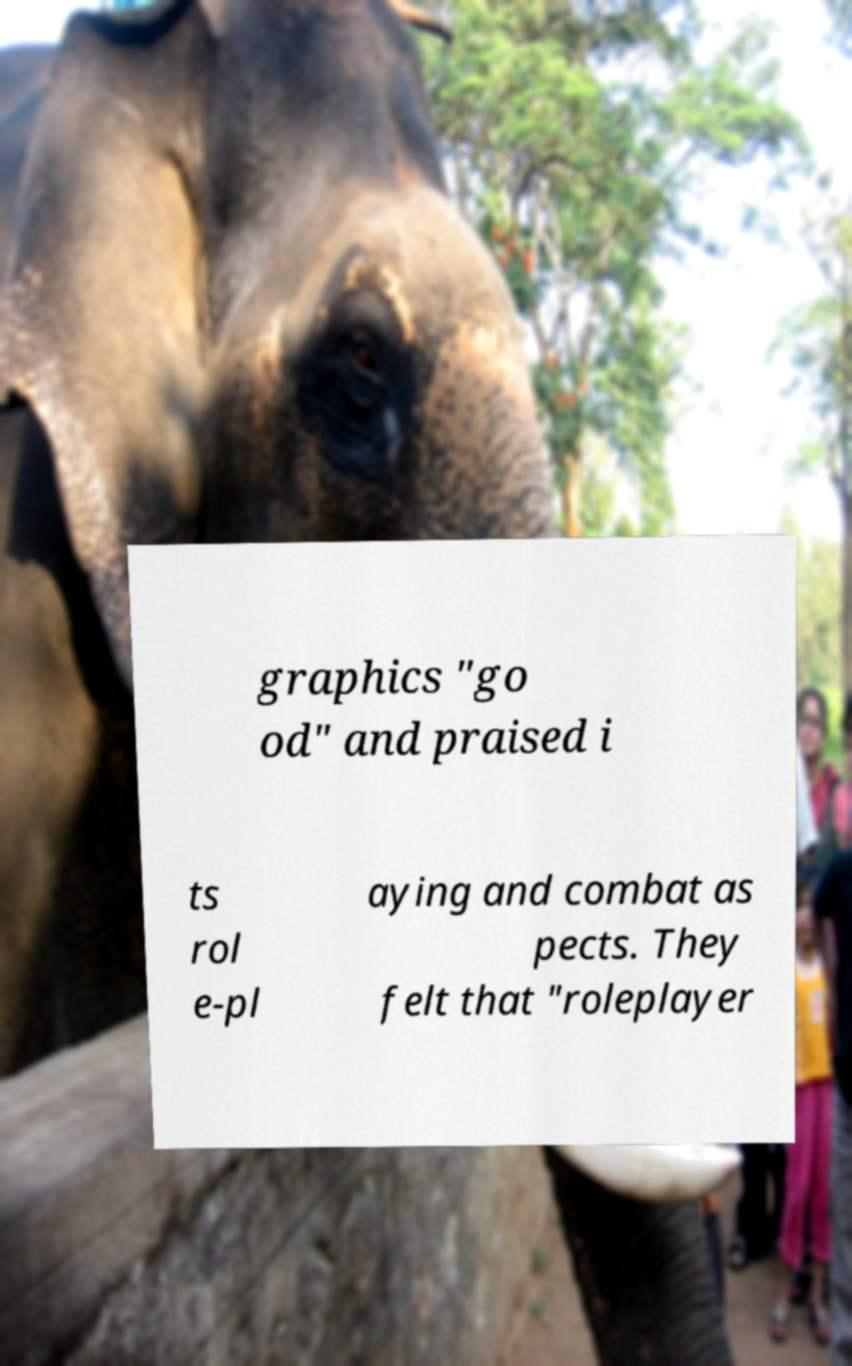Please read and relay the text visible in this image. What does it say? graphics "go od" and praised i ts rol e-pl aying and combat as pects. They felt that "roleplayer 